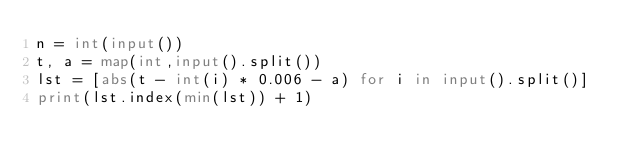Convert code to text. <code><loc_0><loc_0><loc_500><loc_500><_Python_>n = int(input())
t, a = map(int,input().split())
lst = [abs(t - int(i) * 0.006 - a) for i in input().split()]
print(lst.index(min(lst)) + 1)
</code> 